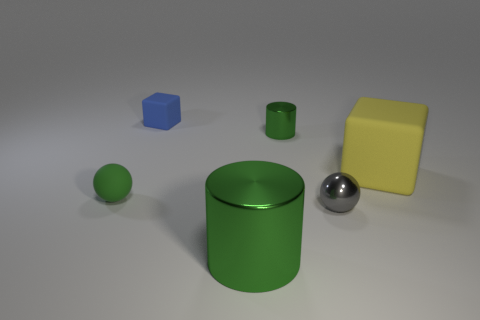How is the lighting arranged in this scene? The lighting in the scene gives off a soft, diffused appearance, suggesting the use of an ambient light source possibly coupled with some softer directional lights to create gentle shadows and highlights, which accentuate the shapes and materials of the objects. 